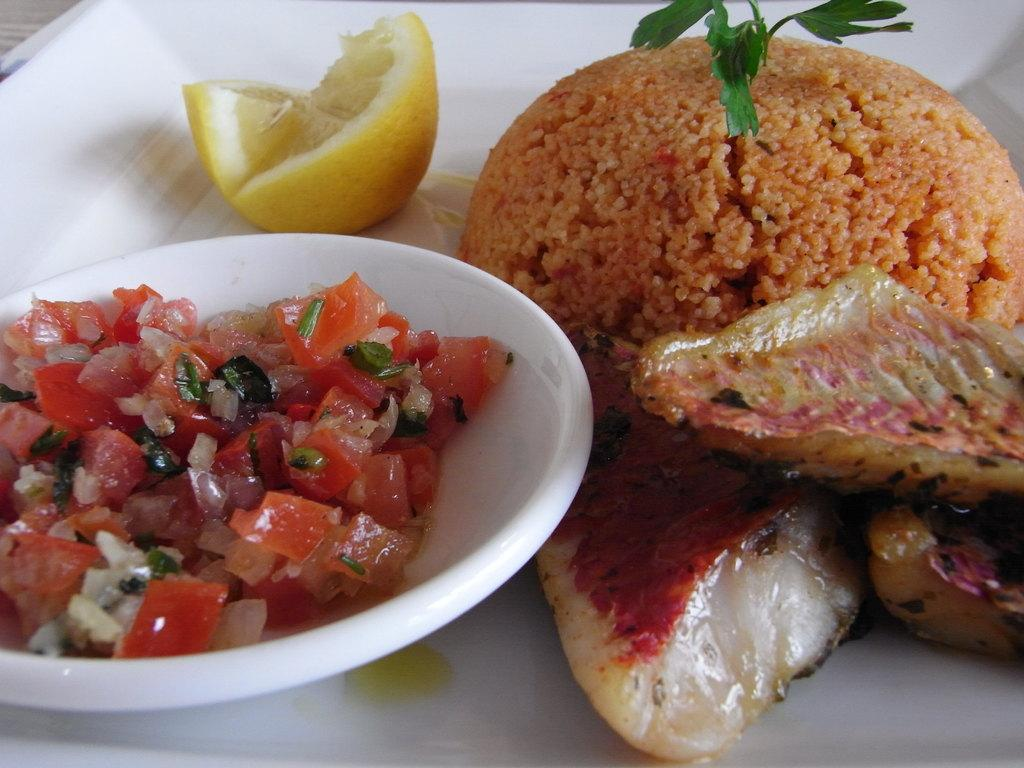What is the color of the plate in the image? The plate is white in color. What is placed on the plate? A: There is a slice of lemon on the plate. What is the other dish in the image? There is a bowl in the image. What is inside the bowl? The bowl contains chopped onion and tomato. What can be inferred about the items on the plate and in the bowl? The items on the plate and in the bowl are considered a food item. What type of silk is draped over the bell in the image? There is no silk or bell present in the image. What type of food is depicted in the image? The food item in the image consists of a slice of lemon, chopped onion, and tomato. 